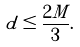<formula> <loc_0><loc_0><loc_500><loc_500>d \leq \frac { 2 M } { 3 } .</formula> 